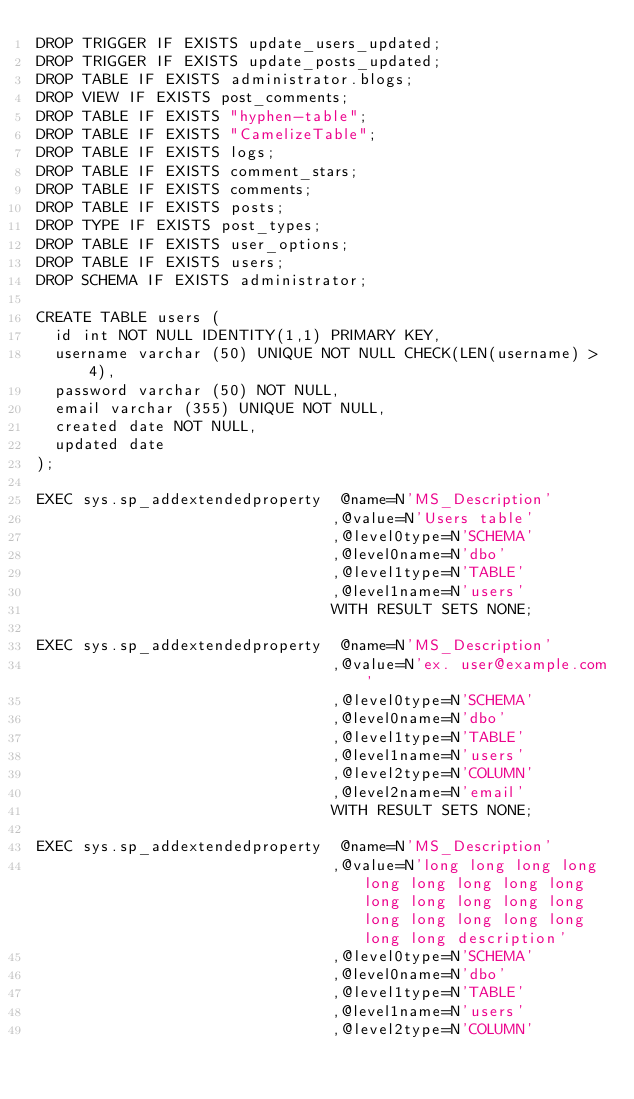<code> <loc_0><loc_0><loc_500><loc_500><_SQL_>DROP TRIGGER IF EXISTS update_users_updated;
DROP TRIGGER IF EXISTS update_posts_updated;
DROP TABLE IF EXISTS administrator.blogs;
DROP VIEW IF EXISTS post_comments;
DROP TABLE IF EXISTS "hyphen-table";
DROP TABLE IF EXISTS "CamelizeTable";
DROP TABLE IF EXISTS logs;
DROP TABLE IF EXISTS comment_stars;
DROP TABLE IF EXISTS comments;
DROP TABLE IF EXISTS posts;
DROP TYPE IF EXISTS post_types;
DROP TABLE IF EXISTS user_options;
DROP TABLE IF EXISTS users;
DROP SCHEMA IF EXISTS administrator;

CREATE TABLE users (
  id int NOT NULL IDENTITY(1,1) PRIMARY KEY,
  username varchar (50) UNIQUE NOT NULL CHECK(LEN(username) > 4),
  password varchar (50) NOT NULL,
  email varchar (355) UNIQUE NOT NULL,
  created date NOT NULL,
  updated date
);

EXEC sys.sp_addextendedproperty  @name=N'MS_Description'
                                ,@value=N'Users table'
                                ,@level0type=N'SCHEMA'
                                ,@level0name=N'dbo'
                                ,@level1type=N'TABLE'
                                ,@level1name=N'users'
                                WITH RESULT SETS NONE;

EXEC sys.sp_addextendedproperty  @name=N'MS_Description'
                                ,@value=N'ex. user@example.com'
                                ,@level0type=N'SCHEMA'
                                ,@level0name=N'dbo'
                                ,@level1type=N'TABLE'
                                ,@level1name=N'users'
                                ,@level2type=N'COLUMN'
                                ,@level2name=N'email'
                                WITH RESULT SETS NONE;

EXEC sys.sp_addextendedproperty  @name=N'MS_Description'
                                ,@value=N'long long long long long long long long long long long long long long long long long long long long long description'
                                ,@level0type=N'SCHEMA'
                                ,@level0name=N'dbo'
                                ,@level1type=N'TABLE'
                                ,@level1name=N'users'
                                ,@level2type=N'COLUMN'</code> 